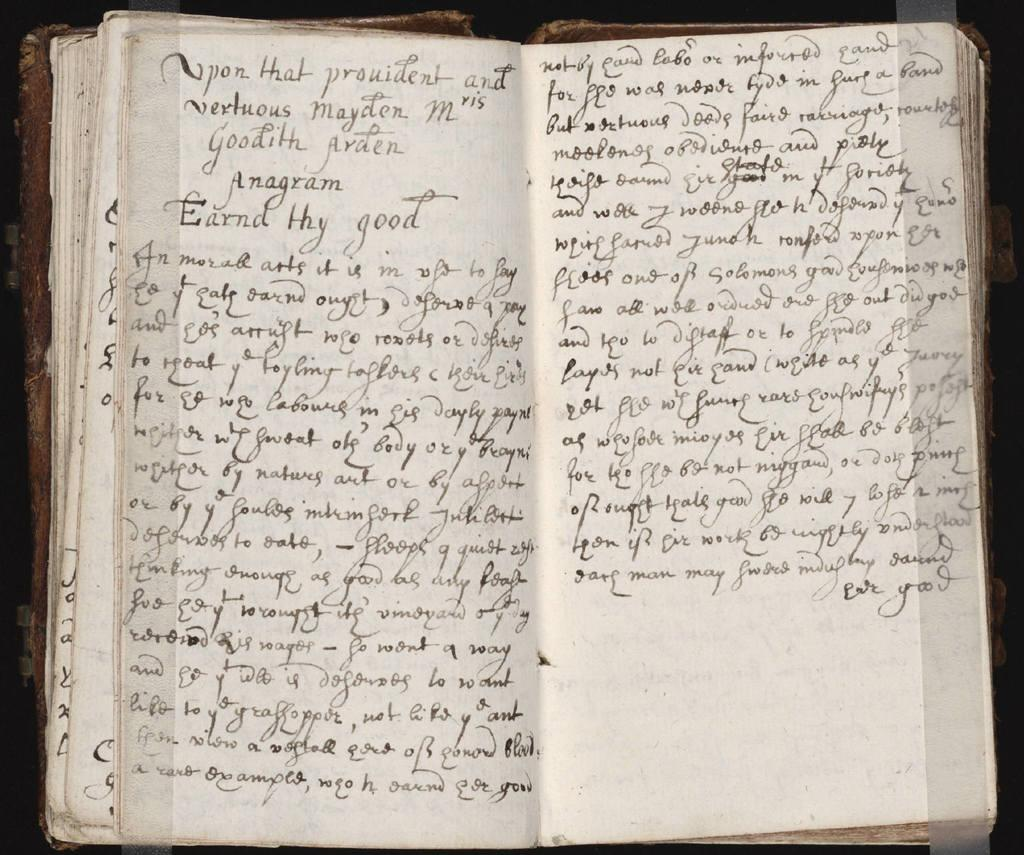<image>
Share a concise interpretation of the image provided. a book with different language writings on it 